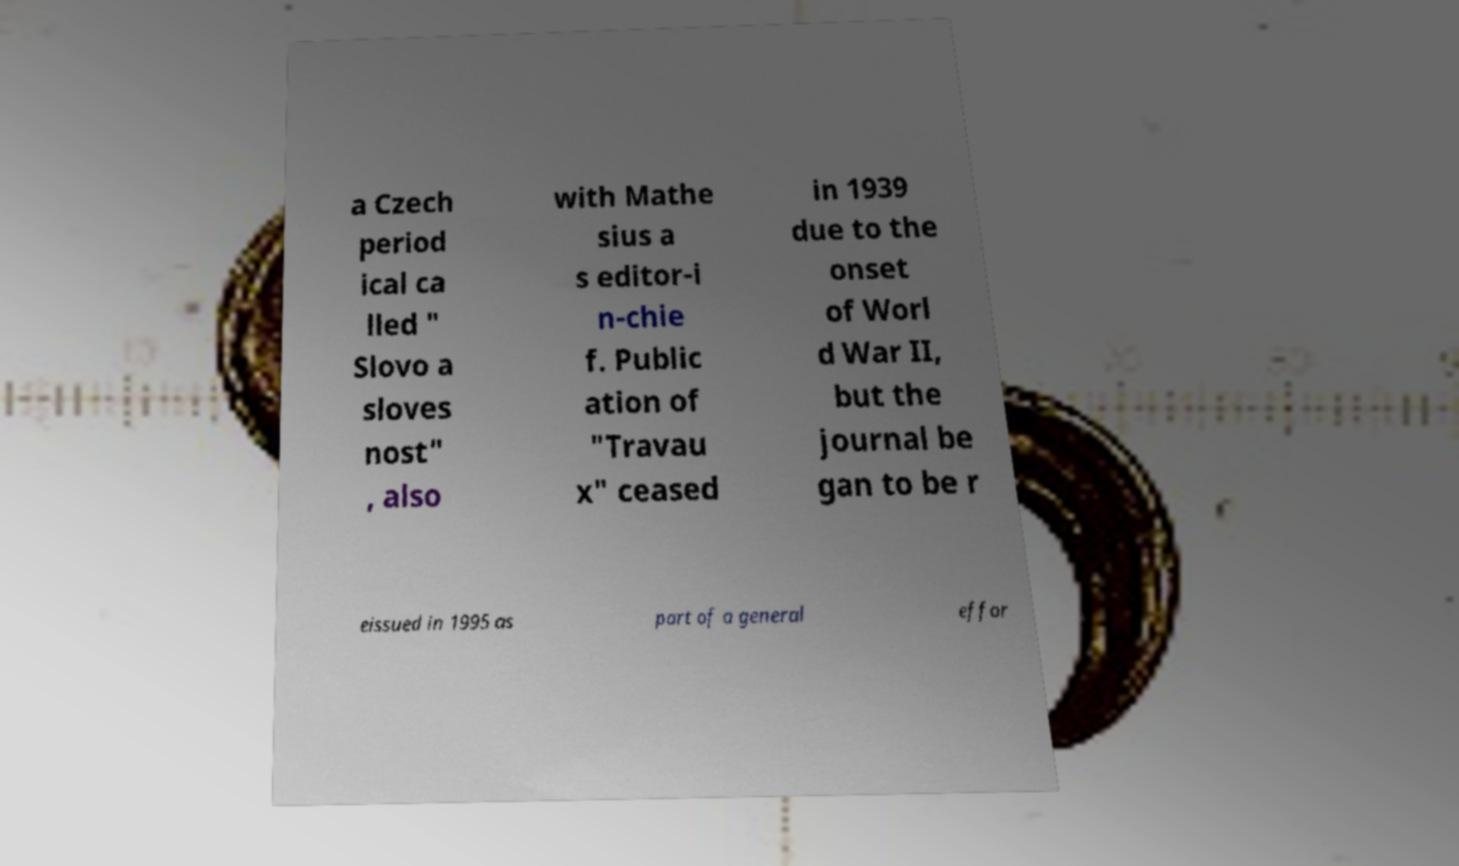Please read and relay the text visible in this image. What does it say? a Czech period ical ca lled " Slovo a sloves nost" , also with Mathe sius a s editor-i n-chie f. Public ation of "Travau x" ceased in 1939 due to the onset of Worl d War II, but the journal be gan to be r eissued in 1995 as part of a general effor 